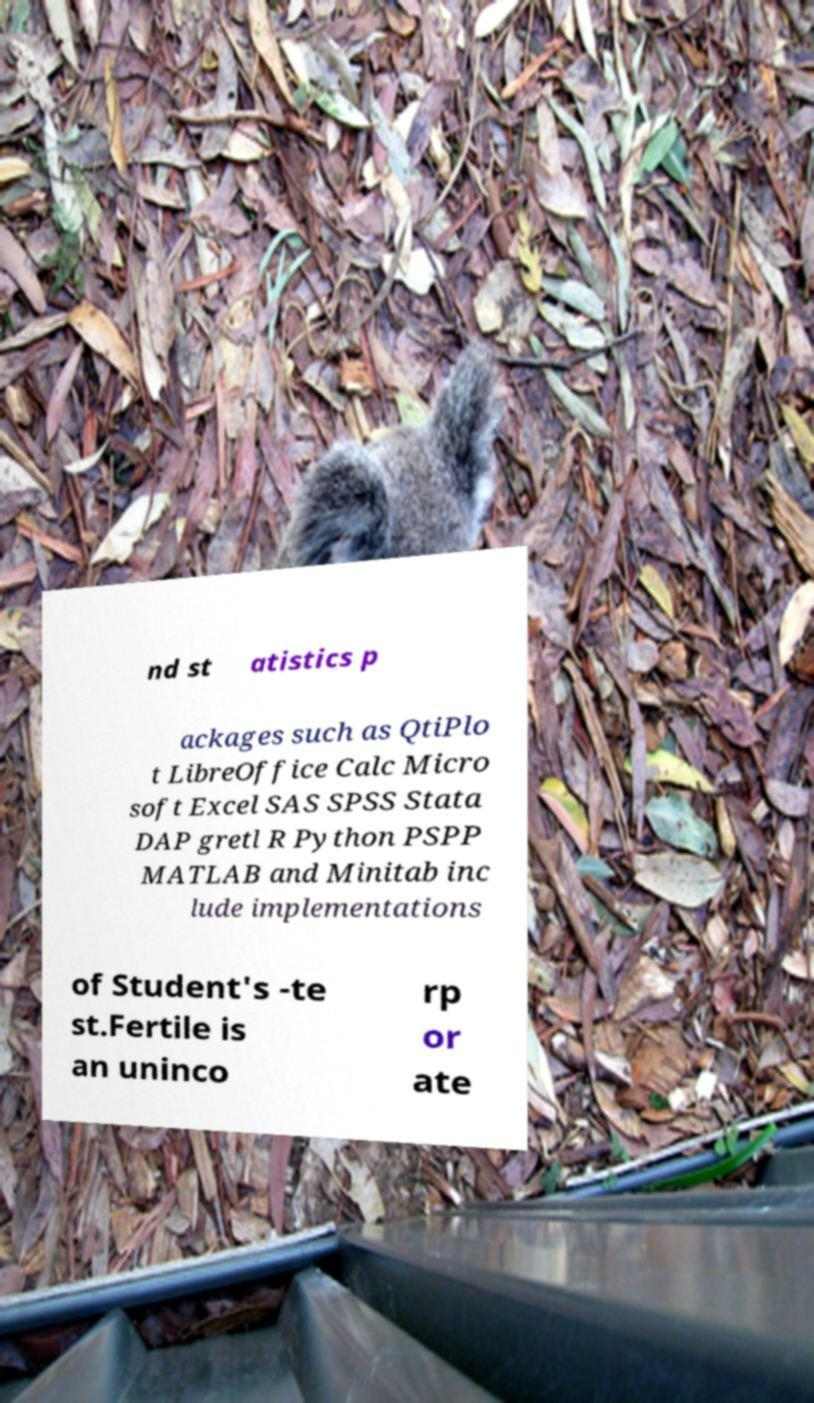Please read and relay the text visible in this image. What does it say? nd st atistics p ackages such as QtiPlo t LibreOffice Calc Micro soft Excel SAS SPSS Stata DAP gretl R Python PSPP MATLAB and Minitab inc lude implementations of Student's -te st.Fertile is an uninco rp or ate 